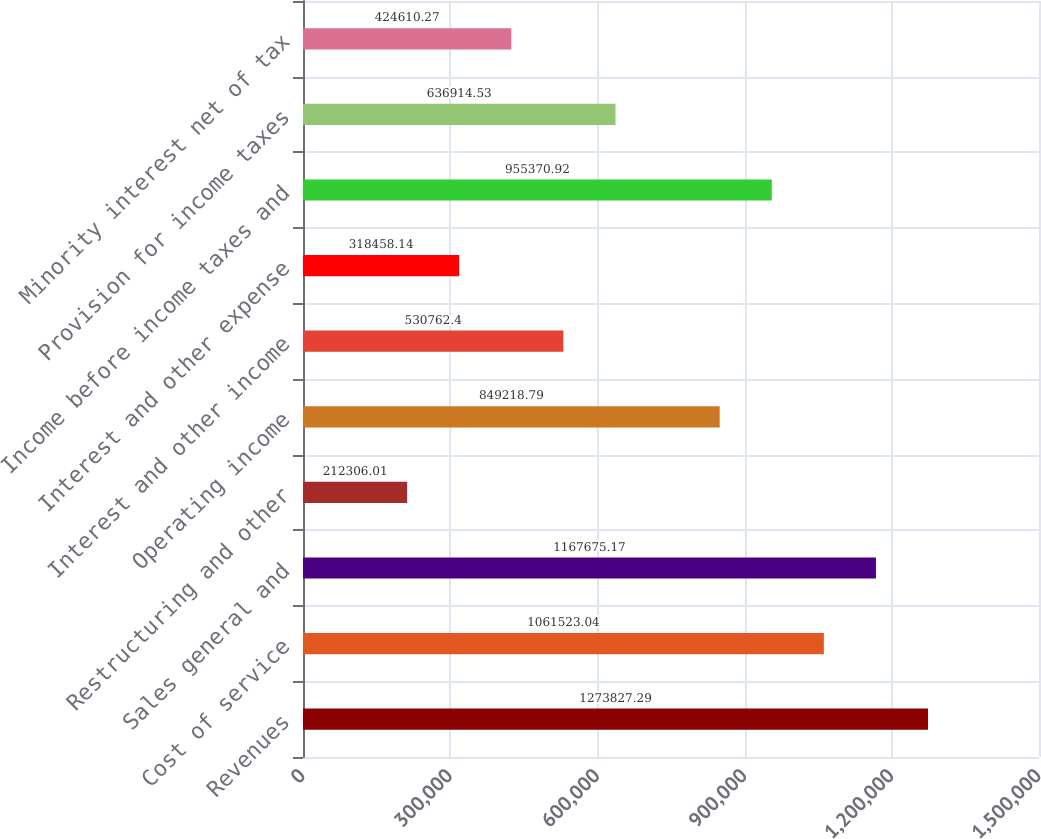Convert chart to OTSL. <chart><loc_0><loc_0><loc_500><loc_500><bar_chart><fcel>Revenues<fcel>Cost of service<fcel>Sales general and<fcel>Restructuring and other<fcel>Operating income<fcel>Interest and other income<fcel>Interest and other expense<fcel>Income before income taxes and<fcel>Provision for income taxes<fcel>Minority interest net of tax<nl><fcel>1.27383e+06<fcel>1.06152e+06<fcel>1.16768e+06<fcel>212306<fcel>849219<fcel>530762<fcel>318458<fcel>955371<fcel>636915<fcel>424610<nl></chart> 